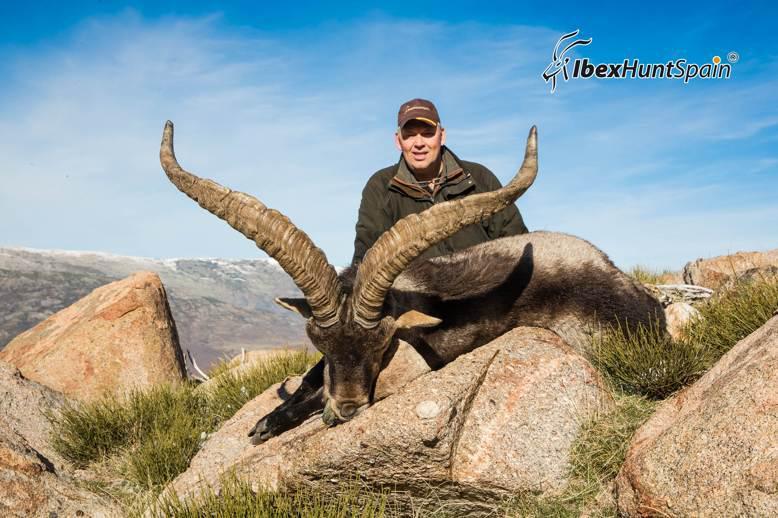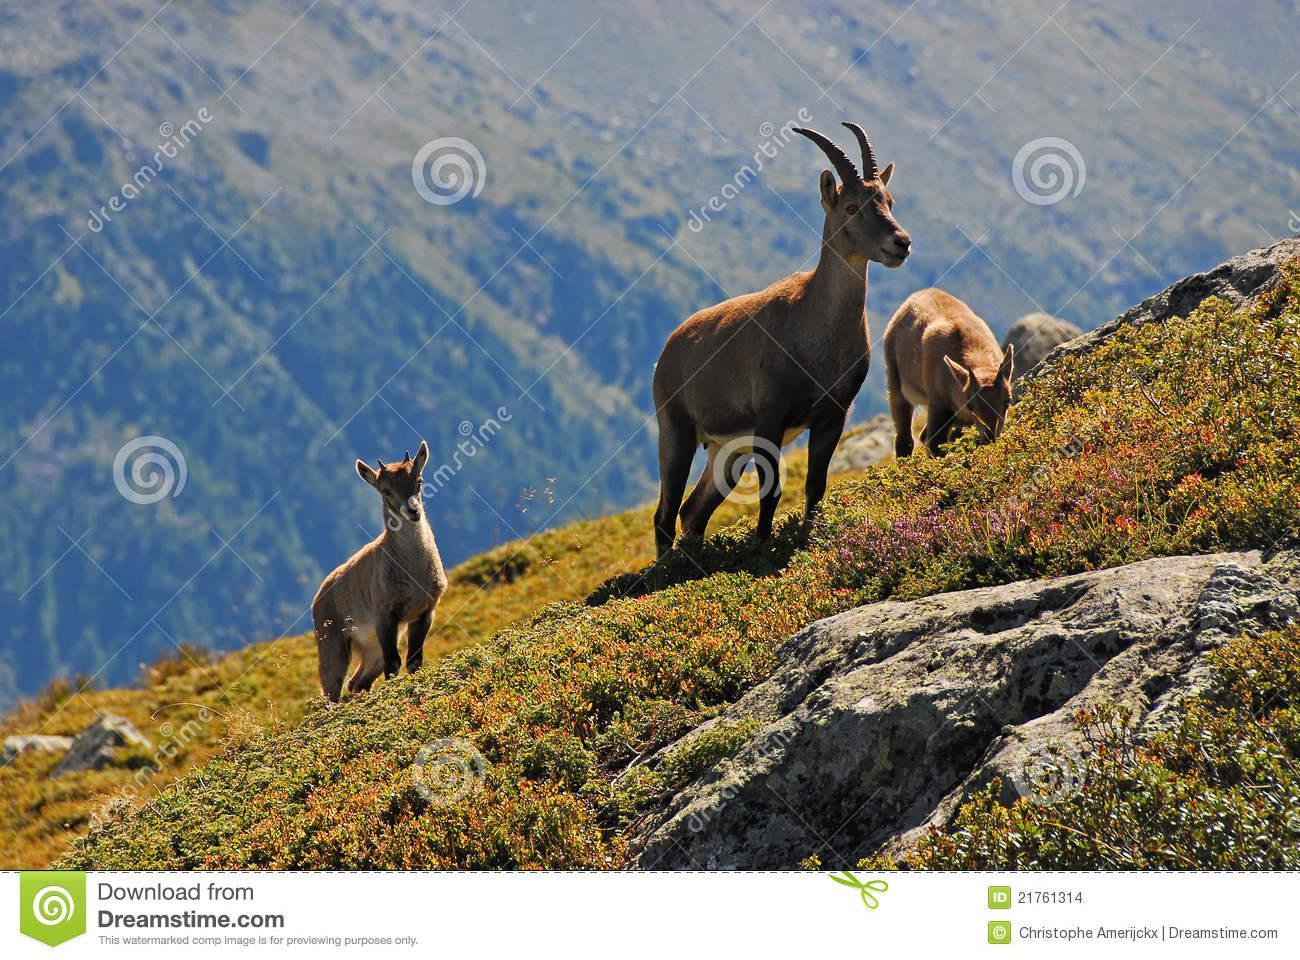The first image is the image on the left, the second image is the image on the right. Considering the images on both sides, is "There are exactly four mountain goats total." valid? Answer yes or no. Yes. The first image is the image on the left, the second image is the image on the right. For the images displayed, is the sentence "One image shows exactly one adult horned animal near at least one juvenile animal with no more than tiny horns." factually correct? Answer yes or no. Yes. 